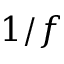<formula> <loc_0><loc_0><loc_500><loc_500>1 / f</formula> 